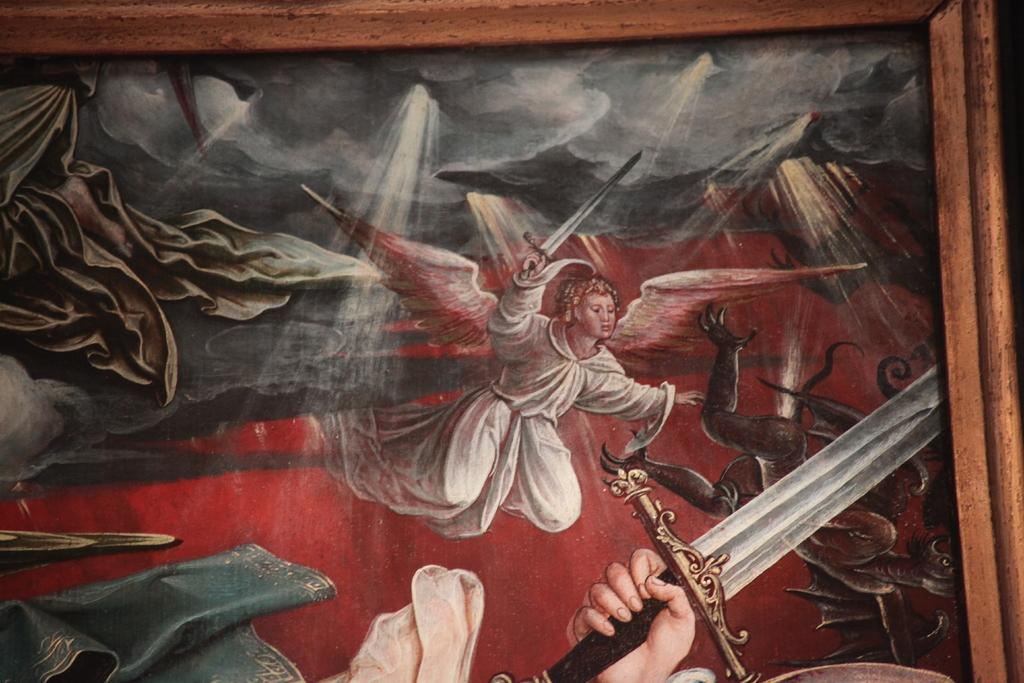What is the main object in the image? There is a photo frame of a painting in the image. How many people are in the image? There are two persons in the image. What are the two persons holding? The two persons are holding swords. How many things can be seen sleeping in the image? There are no things or objects depicted as sleeping in the image. What type of pail is visible in the image? There is no pail present in the image. 